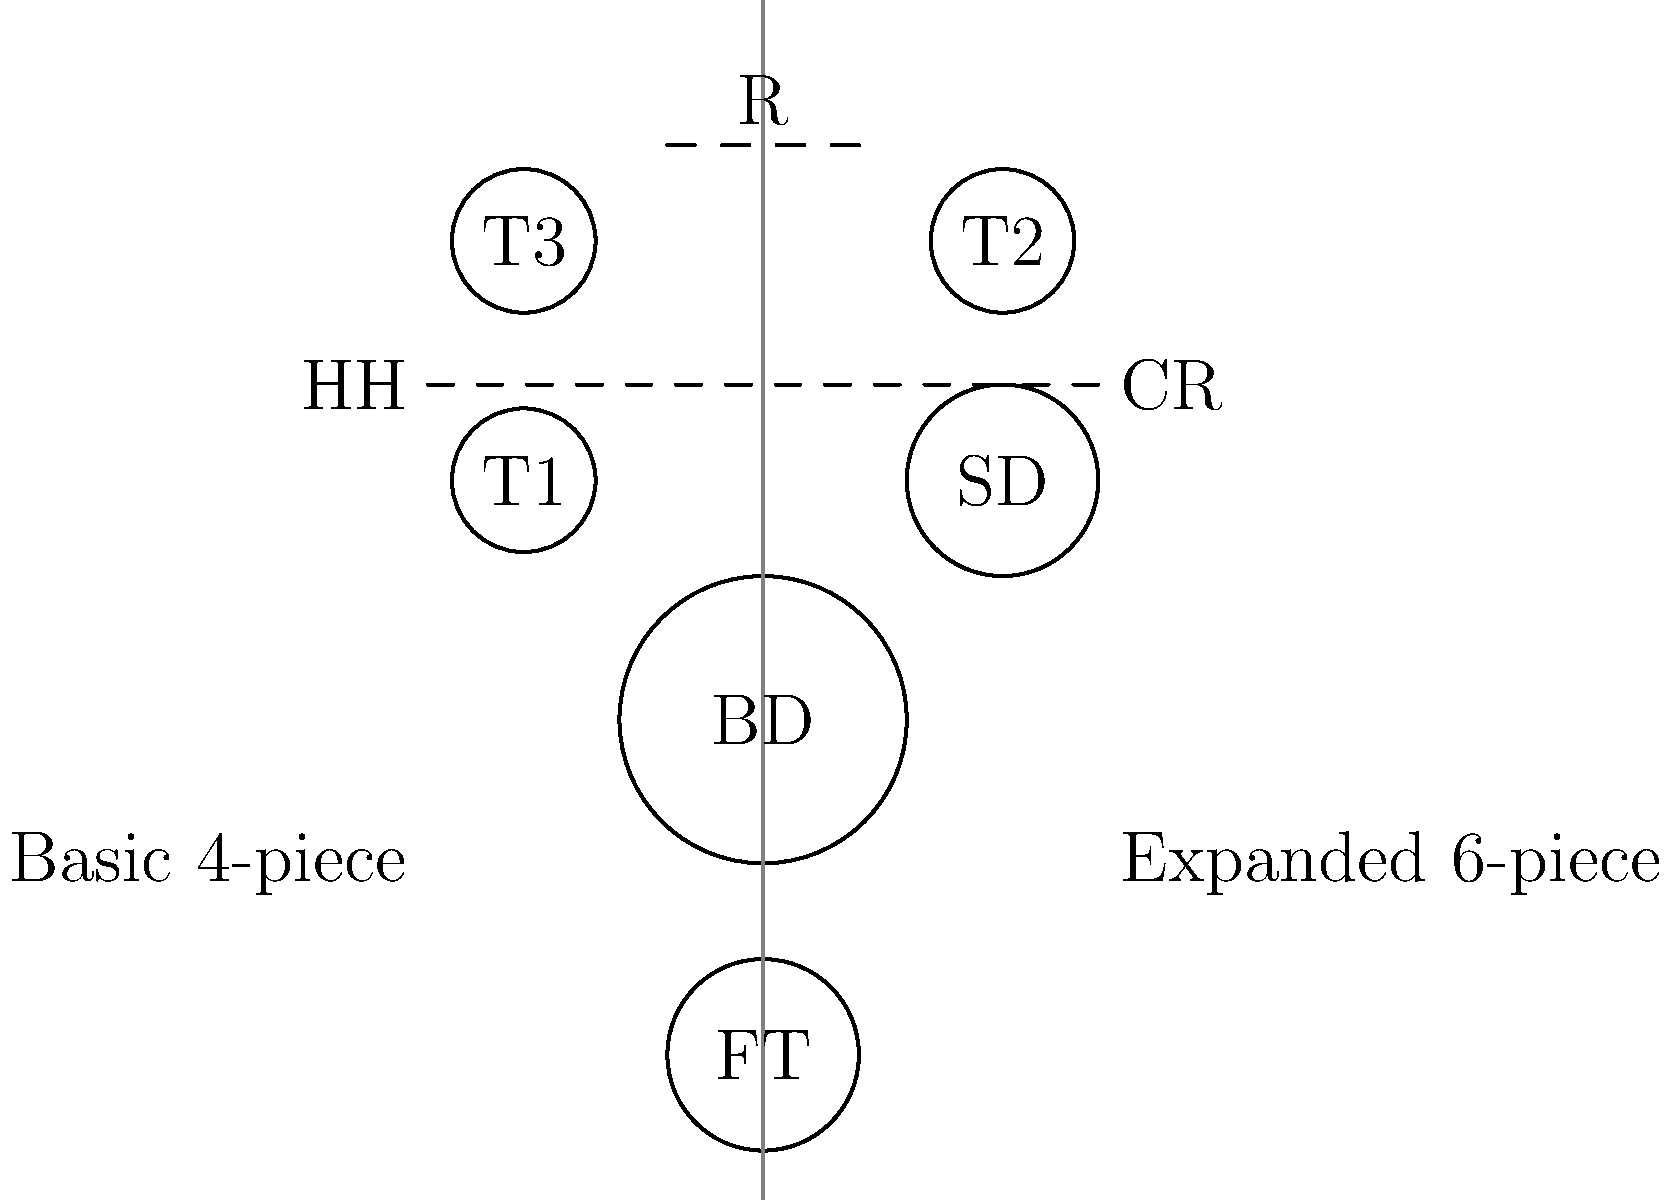In the diagram comparing basic and expanded drum kit configurations, which additional drum is typically added to create a fuller, deeper sound in classic rock? To answer this question, let's analyze the diagram step-by-step:

1. The left side of the diagram shows a basic 4-piece drum kit, which includes:
   - BD (Bass Drum)
   - SD (Snare Drum)
   - T1 and T2 (Two Tom-toms)
   - HH (Hi-Hat) and CR (Crash) cymbals
   - R (Ride) cymbal

2. The right side shows an expanded 6-piece kit, which adds two more drums:
   - T3 (A third Tom-tom)
   - FT (Floor Tom)

3. In classic rock, drummers often sought to create a fuller, deeper sound to complement the powerful guitar riffs and bass lines.

4. Among the added drums, the Floor Tom (FT) is typically larger and produces a deeper, more resonant sound compared to the smaller mounted toms (T1, T2, T3).

5. The Floor Tom is usually positioned lower than the other toms, allowing the drummer to create powerful, low-end fills and patterns that are characteristic of classic rock drumming.

6. While the additional tom (T3) adds more tonal options, it's the Floor Tom that contributes most significantly to the fuller, deeper sound typical of classic rock drum kits.

Therefore, the Floor Tom (FT) is the additional drum typically added to create a fuller, deeper sound in classic rock.
Answer: Floor Tom (FT) 